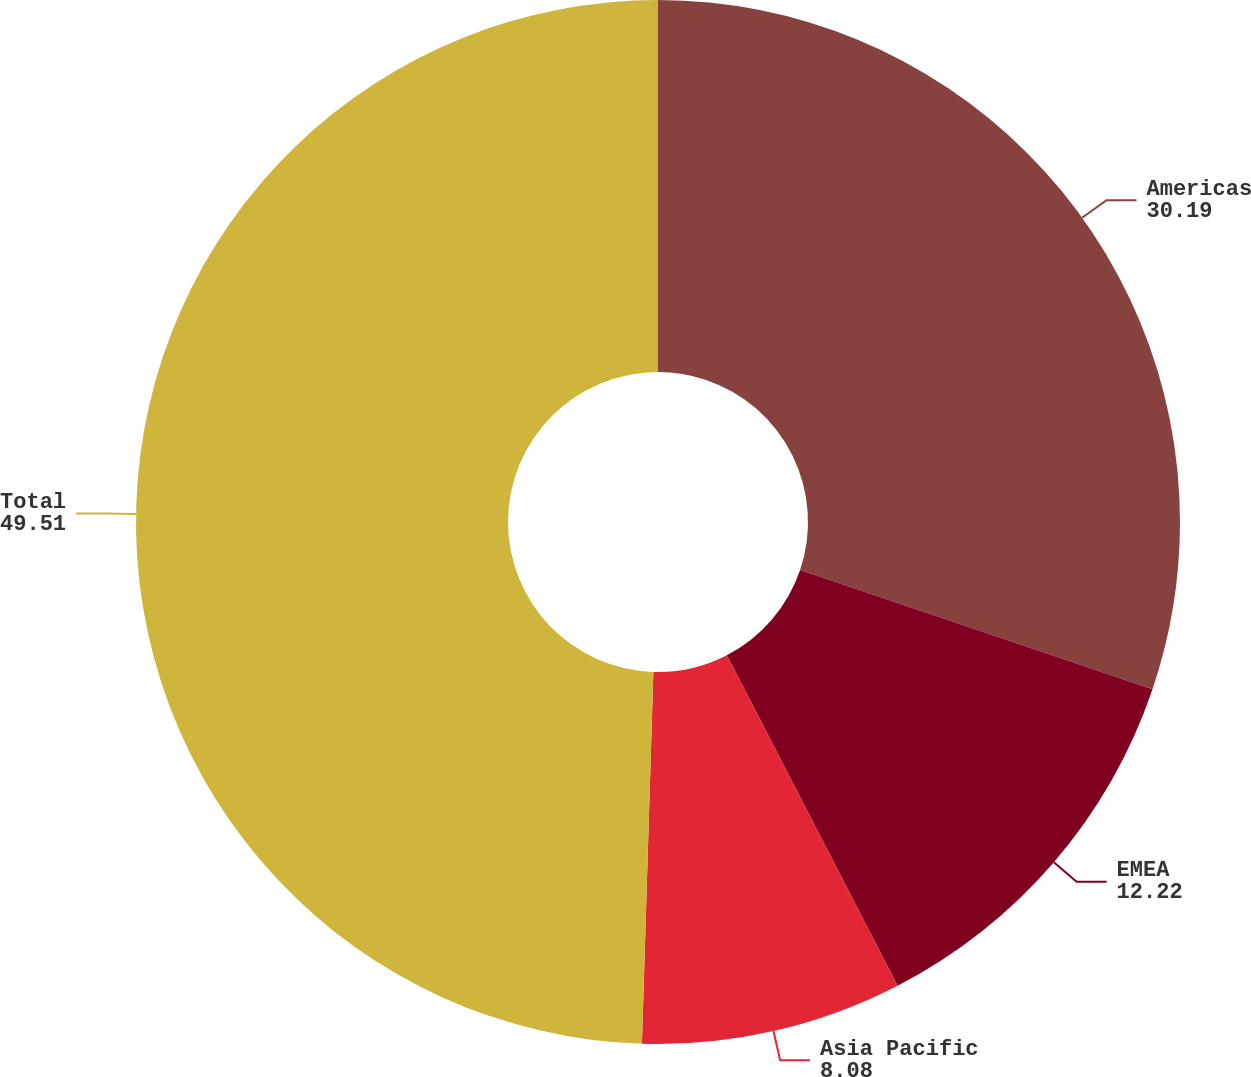Convert chart. <chart><loc_0><loc_0><loc_500><loc_500><pie_chart><fcel>Americas<fcel>EMEA<fcel>Asia Pacific<fcel>Total<nl><fcel>30.19%<fcel>12.22%<fcel>8.08%<fcel>49.51%<nl></chart> 